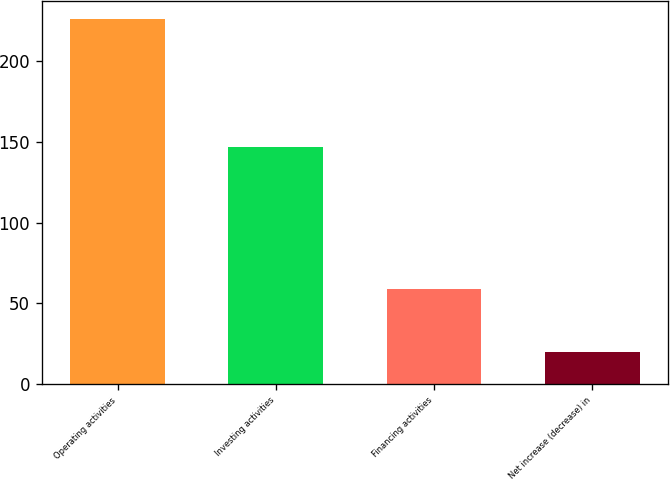<chart> <loc_0><loc_0><loc_500><loc_500><bar_chart><fcel>Operating activities<fcel>Investing activities<fcel>Financing activities<fcel>Net increase (decrease) in<nl><fcel>226<fcel>147<fcel>59<fcel>20<nl></chart> 